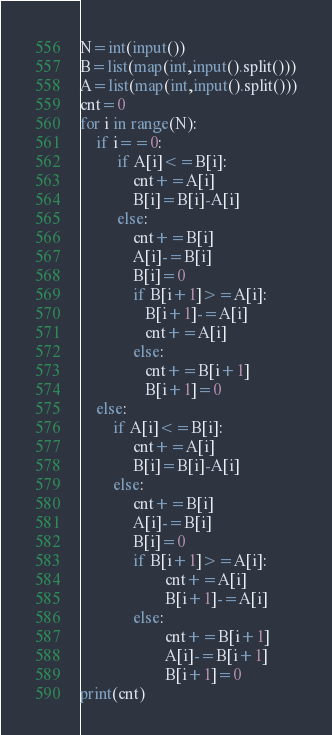Convert code to text. <code><loc_0><loc_0><loc_500><loc_500><_Python_>N=int(input())
B=list(map(int,input().split()))
A=list(map(int,input().split()))
cnt=0
for i in range(N):
    if i==0:
         if A[i]<=B[i]:
             cnt+=A[i]
             B[i]=B[i]-A[i]
         else:
             cnt+=B[i]
             A[i]-=B[i]
             B[i]=0
             if B[i+1]>=A[i]:
                B[i+1]-=A[i]
                cnt+=A[i]
             else:
                cnt+=B[i+1]
                B[i+1]=0
    else:
        if A[i]<=B[i]:
             cnt+=A[i]
             B[i]=B[i]-A[i]
        else:
             cnt+=B[i]
             A[i]-=B[i]
             B[i]=0
             if B[i+1]>=A[i]:
                     cnt+=A[i]
                     B[i+1]-=A[i]
             else:
                     cnt+=B[i+1]
                     A[i]-=B[i+1]
                     B[i+1]=0
print(cnt)</code> 